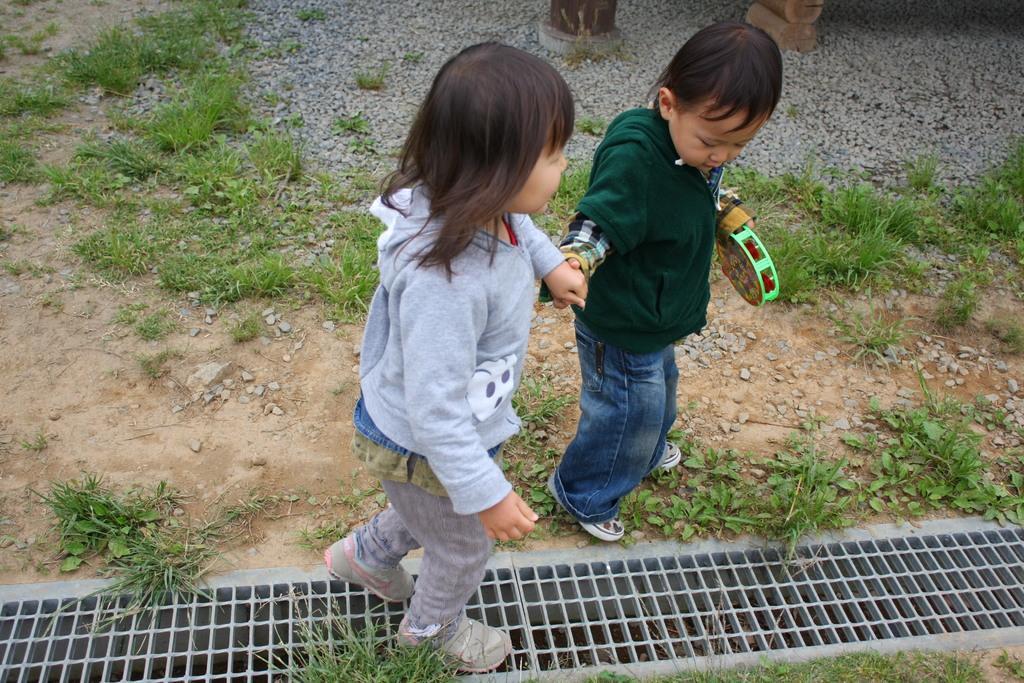Can you describe this image briefly? This picture shows a boy and a girl walking. Boy holding hand of a girl with one hand and a toy with his another hand and we see grass and stones on the ground. 